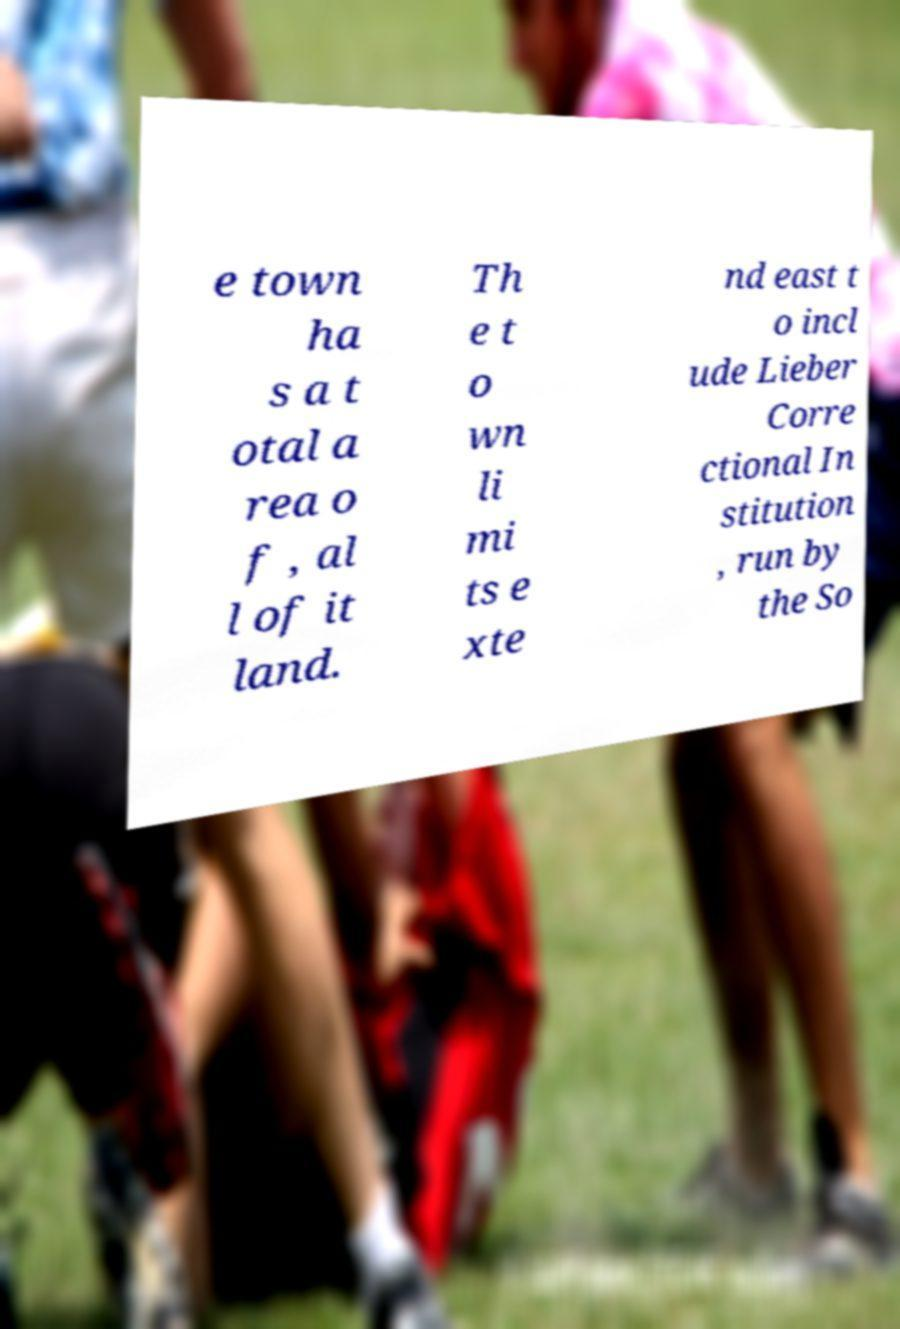For documentation purposes, I need the text within this image transcribed. Could you provide that? e town ha s a t otal a rea o f , al l of it land. Th e t o wn li mi ts e xte nd east t o incl ude Lieber Corre ctional In stitution , run by the So 